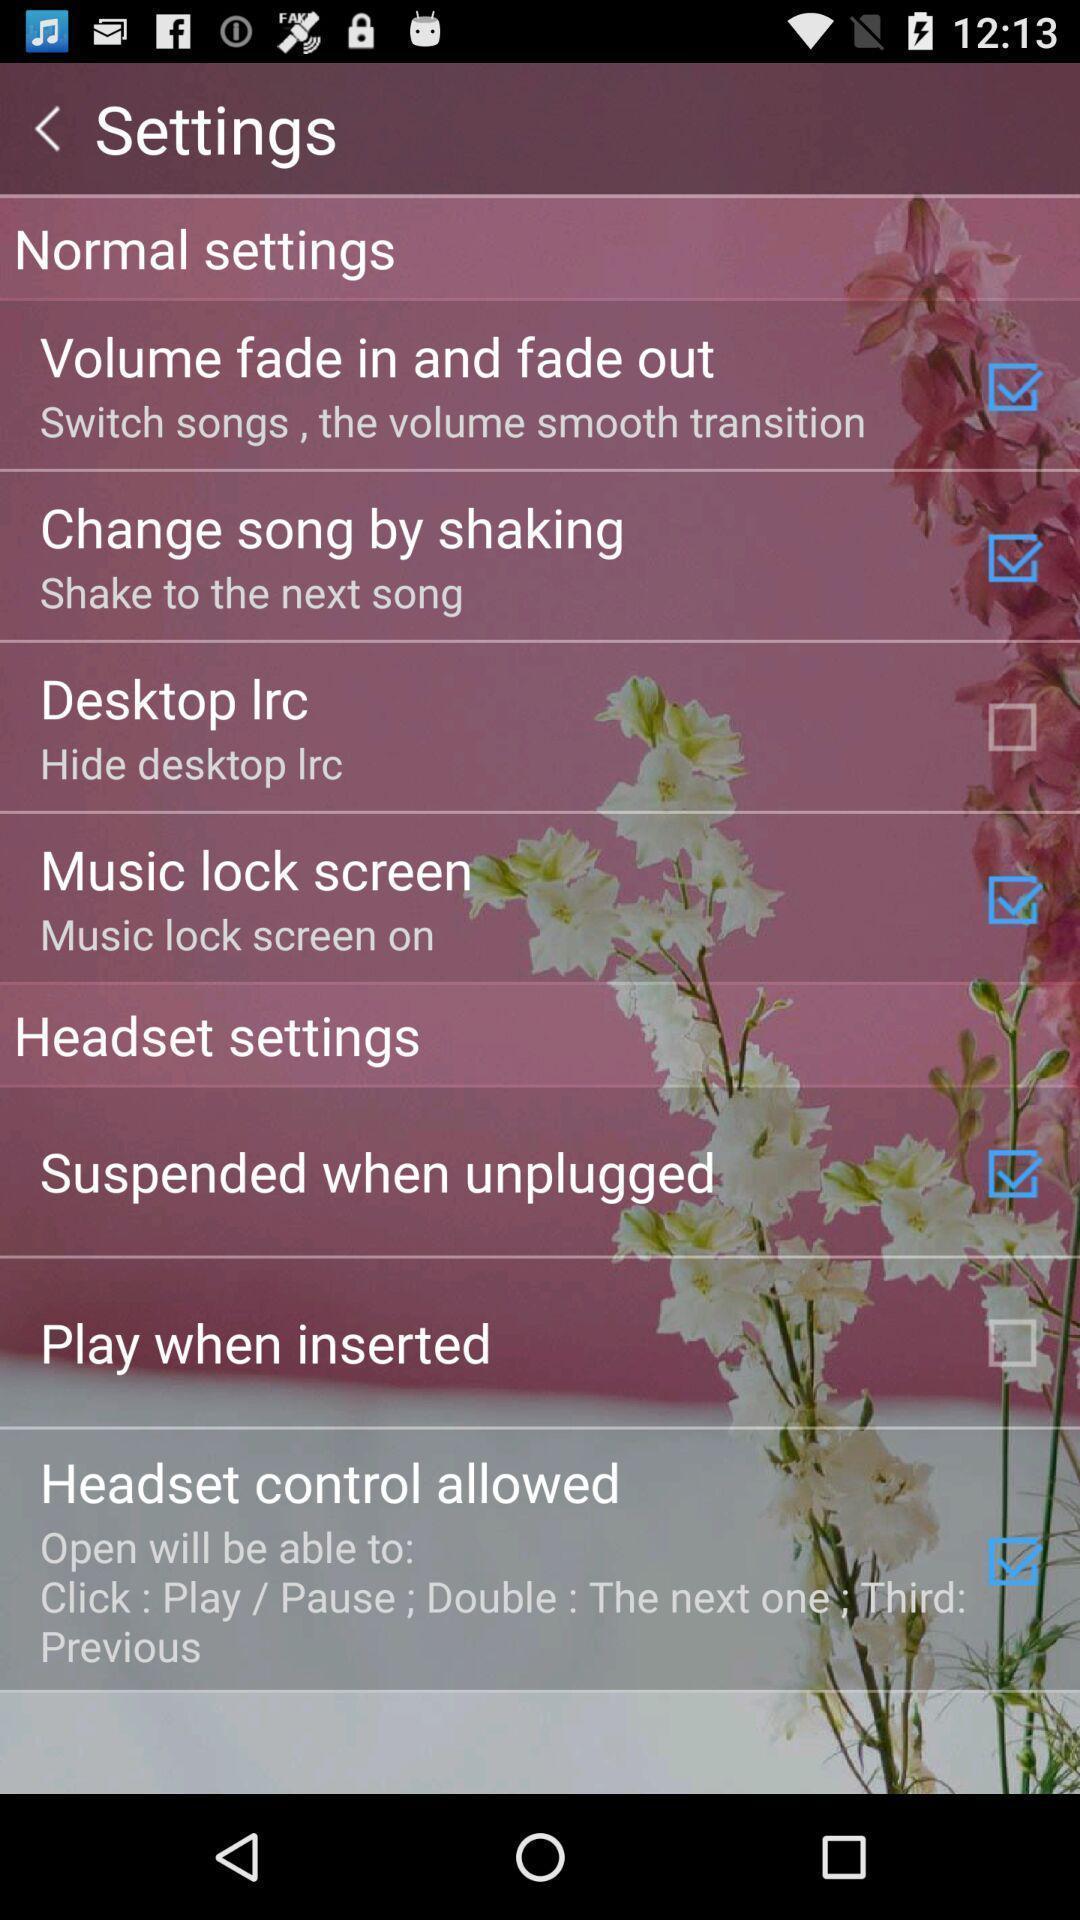Describe the visual elements of this screenshot. Page showing different options in settings. 